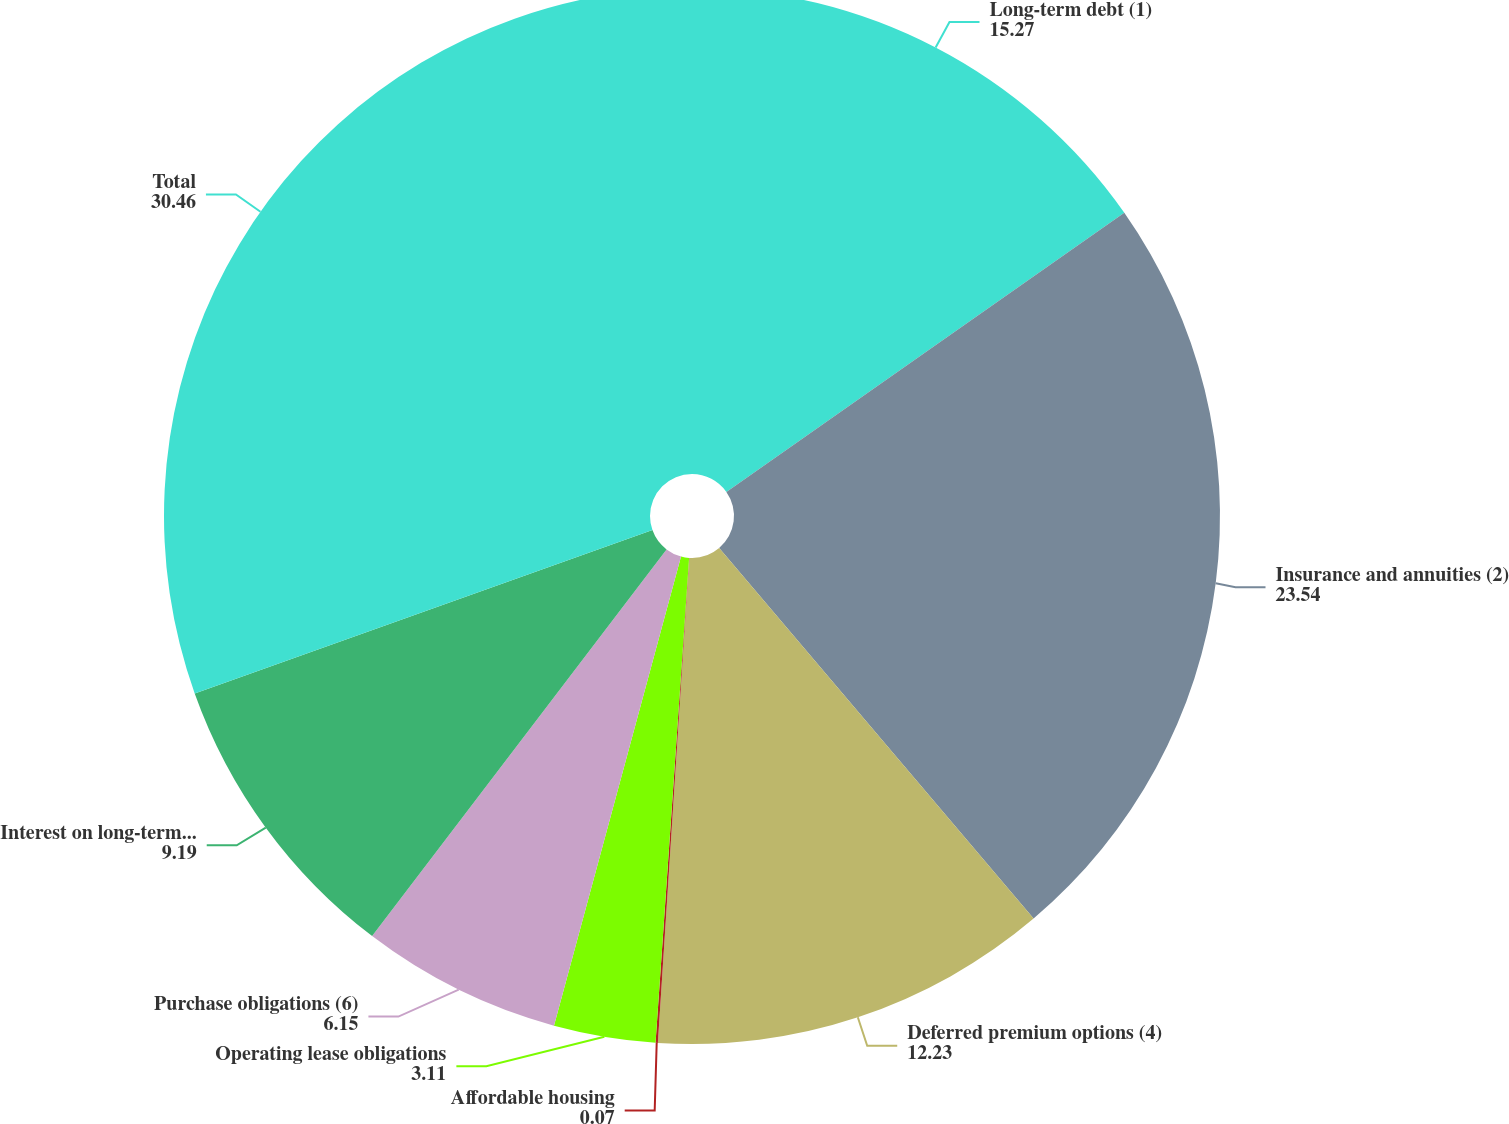Convert chart. <chart><loc_0><loc_0><loc_500><loc_500><pie_chart><fcel>Long-term debt (1)<fcel>Insurance and annuities (2)<fcel>Deferred premium options (4)<fcel>Affordable housing<fcel>Operating lease obligations<fcel>Purchase obligations (6)<fcel>Interest on long-term debt (7)<fcel>Total<nl><fcel>15.27%<fcel>23.54%<fcel>12.23%<fcel>0.07%<fcel>3.11%<fcel>6.15%<fcel>9.19%<fcel>30.46%<nl></chart> 